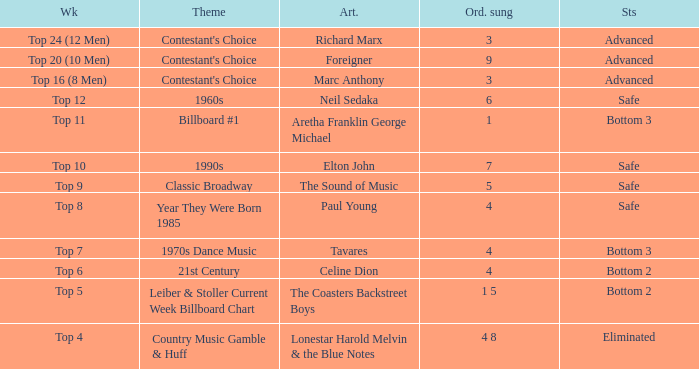What was the theme for the Top 11 week? Billboard #1. 